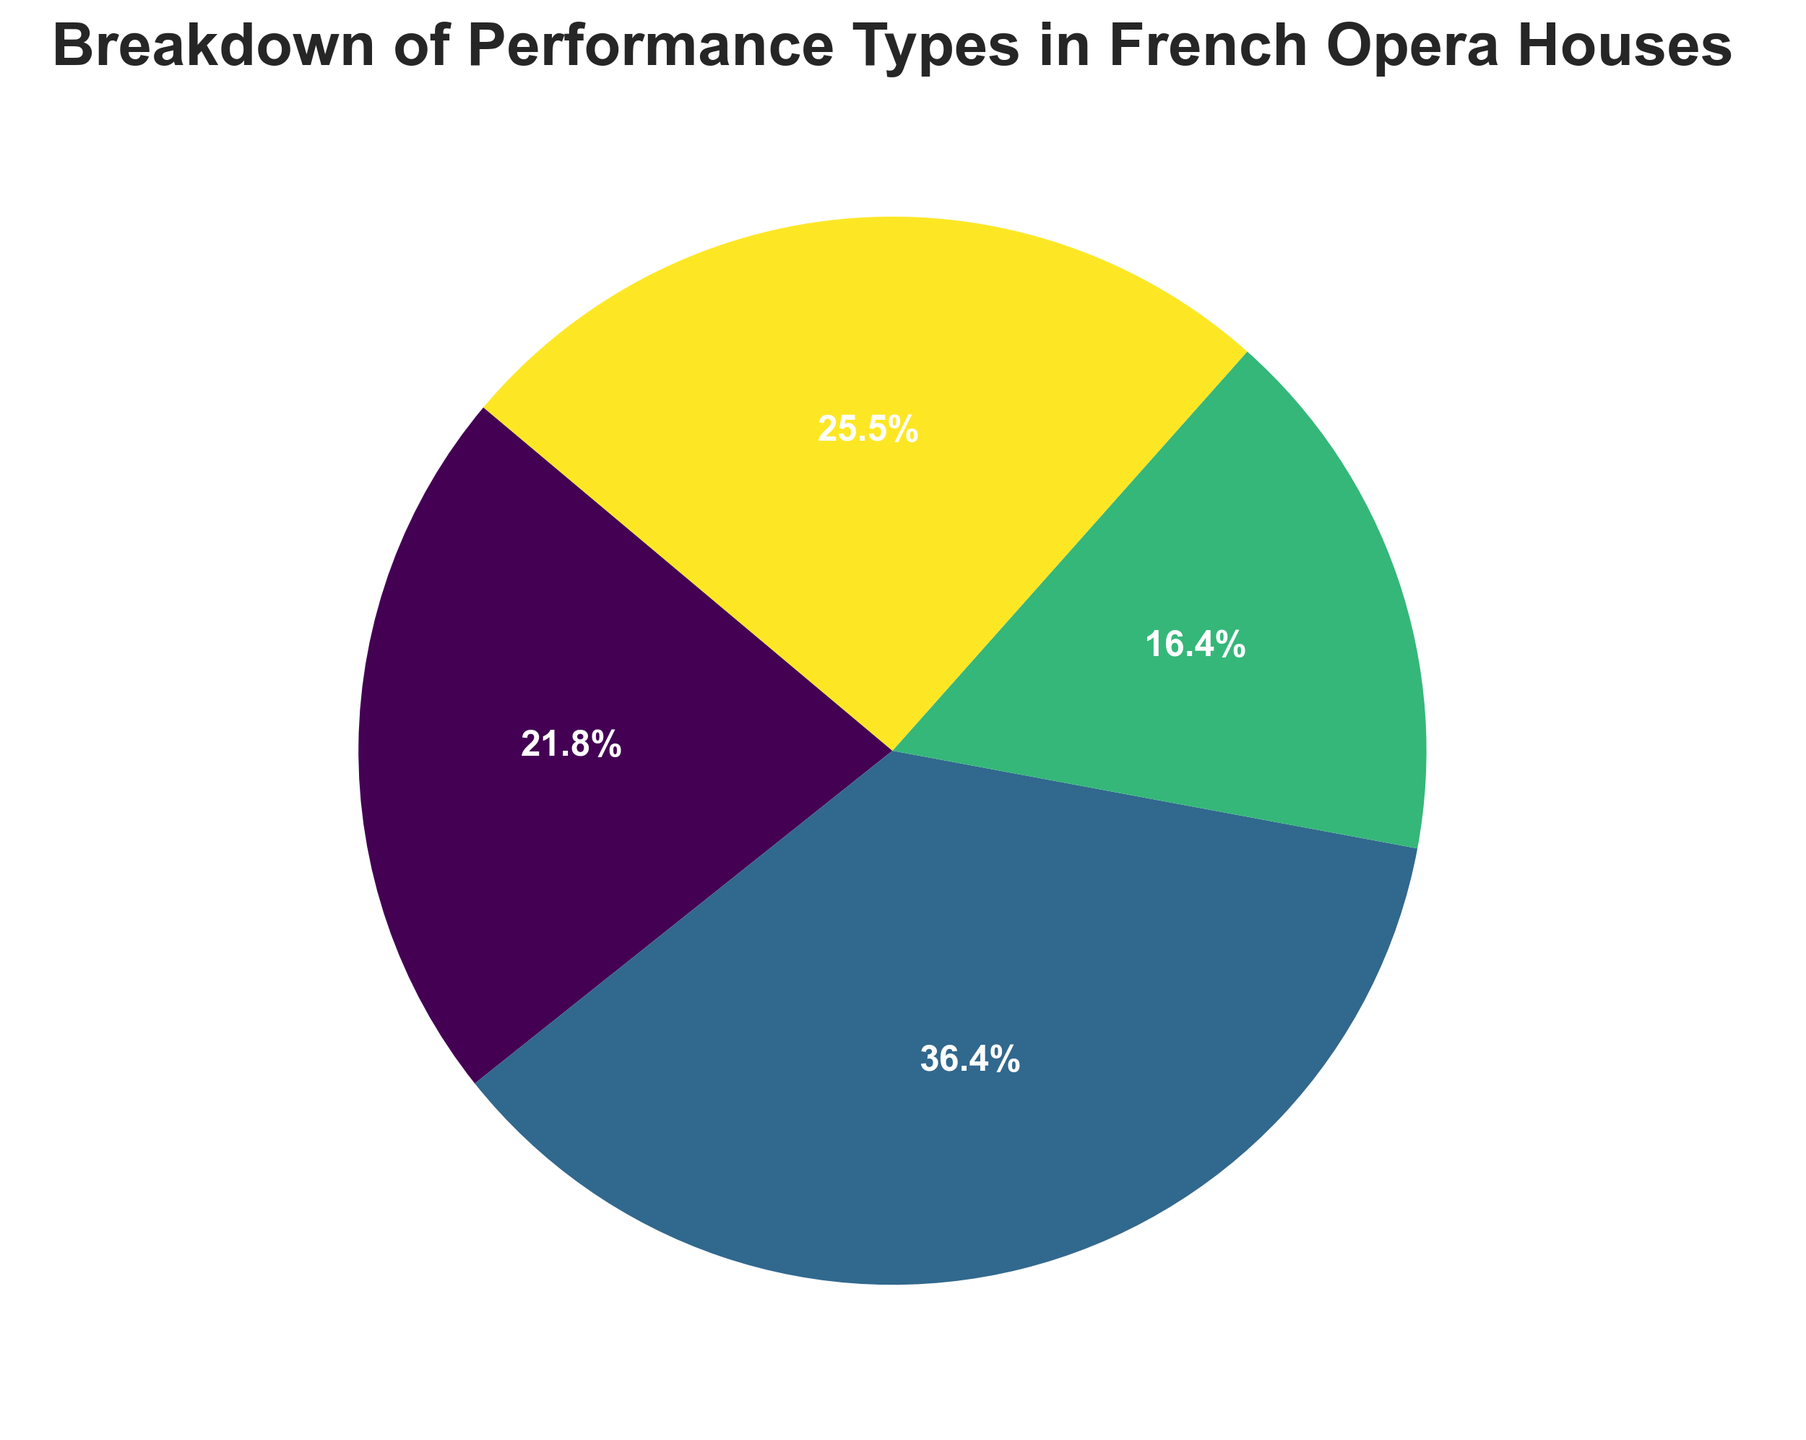Which performance type has the highest count? The pie chart shows that Full Opera Productions have the largest segment.
Answer: Full Opera Productions Which performance type has the smallest count? The pie chart indicates that Chamber Music has the smallest segment.
Answer: Chamber Music What is the combined percentage of Solo Recitals and Orchestral Concerts? Solo Recitals account for 120 out of 550 total performances and Orchestral Concerts account for 140 out of 550 total performances. The combined percentage is calculated by (120 + 140) / 550 * 100 = 47.27%.
Answer: 47.3% How much larger is the count of Full Opera Productions compared to Chamber Music? Full Opera Productions have a count of 200 and Chamber Music has a count of 90. The difference is 200 - 90 = 110.
Answer: 110 By how much does the count of Orchestral Concerts exceed the count of Chamber Music? Orchestral Concerts have a count of 140 and Chamber Music has a count of 90. The difference is 140 - 90 = 50.
Answer: 50 What percentage of the performances are not Full Opera Productions? The count of Full Opera Productions is 200 out of a total of 550. The percentage not accounted for by Full Opera Productions is (550 - 200) / 550 * 100 = 63.64%.
Answer: 63.6% Which performance types together make up less than half of the total performances? The counts for Solo Recitals and Chamber Music are 120 and 90 respectively. Adding these gives 120 + 90 = 210, which is less than half of the total 550 performances.
Answer: Solo Recitals and Chamber Music What is the percentage difference between Solo Recitals and Chamber Music? Solo Recitals have 120 performances, Chamber Music has 90. The percentage difference is ((120 - 90) / ((120 + 90) / 2)) * 100 = 28.57%.
Answer: 28.6% Which segment uses the darkest color in the pie chart? The pie chart shows that the color intensity increases as performance count increases. Full Opera Productions, having the highest count, use the darkest color.
Answer: Full Opera Productions 